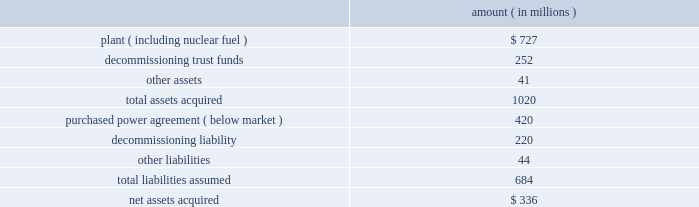Entergy corporation and subsidiaries notes to financial statements amount ( in millions ) .
Subsequent to the closing , entergy received approximately $ 6 million from consumers energy company as part of the post-closing adjustment defined in the asset sale agreement .
The post-closing adjustment amount resulted in an approximately $ 6 million reduction in plant and a corresponding reduction in other liabilities .
For the ppa , which was at below-market prices at the time of the acquisition , non-utility nuclear will amortize a liability to revenue over the life of the agreement .
The amount that will be amortized each period is based upon the difference between the present value calculated at the date of acquisition of each year's difference between revenue under the agreement and revenue based on estimated market prices .
Amounts amortized to revenue were $ 53 million in 2009 , $ 76 million in 2008 , and $ 50 million in 2007 .
The amounts to be amortized to revenue for the next five years will be $ 46 million for 2010 , $ 43 million for 2011 , $ 17 million in 2012 , $ 18 million for 2013 , and $ 16 million for 2014 .
Nypa value sharing agreements non-utility nuclear's purchase of the fitzpatrick and indian point 3 plants from nypa included value sharing agreements with nypa .
In october 2007 , non-utility nuclear and nypa amended and restated the value sharing agreements to clarify and amend certain provisions of the original terms .
Under the amended value sharing agreements , non-utility nuclear will make annual payments to nypa based on the generation output of the indian point 3 and fitzpatrick plants from january 2007 through december 2014 .
Non-utility nuclear will pay nypa $ 6.59 per mwh for power sold from indian point 3 , up to an annual cap of $ 48 million , and $ 3.91 per mwh for power sold from fitzpatrick , up to an annual cap of $ 24 million .
The annual payment for each year's output is due by january 15 of the following year .
Non-utility nuclear will record its liability for payments to nypa as power is generated and sold by indian point 3 and fitzpatrick .
An amount equal to the liability will be recorded to the plant asset account as contingent purchase price consideration for the plants .
In 2009 , 2008 , and 2007 , non-utility nuclear recorded $ 72 million as plant for generation during each of those years .
This amount will be depreciated over the expected remaining useful life of the plants .
In august 2008 , non-utility nuclear entered into a resolution of a dispute with nypa over the applicability of the value sharing agreements to its fitzpatrick and indian point 3 nuclear power plants after the planned spin-off of the non-utility nuclear business .
Under the resolution , non-utility nuclear agreed not to treat the separation as a "cessation event" that would terminate its obligation to make the payments under the value sharing agreements .
As a result , after the spin-off transaction , enexus will continue to be obligated to make payments to nypa under the amended and restated value sharing agreements. .
What is the total amount amortized to revenue in the last three years , ( in millions ) ? 
Computations: ((53 + 76) + 50)
Answer: 179.0. Entergy corporation and subsidiaries notes to financial statements amount ( in millions ) .
Subsequent to the closing , entergy received approximately $ 6 million from consumers energy company as part of the post-closing adjustment defined in the asset sale agreement .
The post-closing adjustment amount resulted in an approximately $ 6 million reduction in plant and a corresponding reduction in other liabilities .
For the ppa , which was at below-market prices at the time of the acquisition , non-utility nuclear will amortize a liability to revenue over the life of the agreement .
The amount that will be amortized each period is based upon the difference between the present value calculated at the date of acquisition of each year's difference between revenue under the agreement and revenue based on estimated market prices .
Amounts amortized to revenue were $ 53 million in 2009 , $ 76 million in 2008 , and $ 50 million in 2007 .
The amounts to be amortized to revenue for the next five years will be $ 46 million for 2010 , $ 43 million for 2011 , $ 17 million in 2012 , $ 18 million for 2013 , and $ 16 million for 2014 .
Nypa value sharing agreements non-utility nuclear's purchase of the fitzpatrick and indian point 3 plants from nypa included value sharing agreements with nypa .
In october 2007 , non-utility nuclear and nypa amended and restated the value sharing agreements to clarify and amend certain provisions of the original terms .
Under the amended value sharing agreements , non-utility nuclear will make annual payments to nypa based on the generation output of the indian point 3 and fitzpatrick plants from january 2007 through december 2014 .
Non-utility nuclear will pay nypa $ 6.59 per mwh for power sold from indian point 3 , up to an annual cap of $ 48 million , and $ 3.91 per mwh for power sold from fitzpatrick , up to an annual cap of $ 24 million .
The annual payment for each year's output is due by january 15 of the following year .
Non-utility nuclear will record its liability for payments to nypa as power is generated and sold by indian point 3 and fitzpatrick .
An amount equal to the liability will be recorded to the plant asset account as contingent purchase price consideration for the plants .
In 2009 , 2008 , and 2007 , non-utility nuclear recorded $ 72 million as plant for generation during each of those years .
This amount will be depreciated over the expected remaining useful life of the plants .
In august 2008 , non-utility nuclear entered into a resolution of a dispute with nypa over the applicability of the value sharing agreements to its fitzpatrick and indian point 3 nuclear power plants after the planned spin-off of the non-utility nuclear business .
Under the resolution , non-utility nuclear agreed not to treat the separation as a "cessation event" that would terminate its obligation to make the payments under the value sharing agreements .
As a result , after the spin-off transaction , enexus will continue to be obligated to make payments to nypa under the amended and restated value sharing agreements. .
What percentage of total acquired assets is related to plant acquisition? 
Computations: (727 / 1020)
Answer: 0.71275. Entergy corporation and subsidiaries notes to financial statements amount ( in millions ) .
Subsequent to the closing , entergy received approximately $ 6 million from consumers energy company as part of the post-closing adjustment defined in the asset sale agreement .
The post-closing adjustment amount resulted in an approximately $ 6 million reduction in plant and a corresponding reduction in other liabilities .
For the ppa , which was at below-market prices at the time of the acquisition , non-utility nuclear will amortize a liability to revenue over the life of the agreement .
The amount that will be amortized each period is based upon the difference between the present value calculated at the date of acquisition of each year's difference between revenue under the agreement and revenue based on estimated market prices .
Amounts amortized to revenue were $ 53 million in 2009 , $ 76 million in 2008 , and $ 50 million in 2007 .
The amounts to be amortized to revenue for the next five years will be $ 46 million for 2010 , $ 43 million for 2011 , $ 17 million in 2012 , $ 18 million for 2013 , and $ 16 million for 2014 .
Nypa value sharing agreements non-utility nuclear's purchase of the fitzpatrick and indian point 3 plants from nypa included value sharing agreements with nypa .
In october 2007 , non-utility nuclear and nypa amended and restated the value sharing agreements to clarify and amend certain provisions of the original terms .
Under the amended value sharing agreements , non-utility nuclear will make annual payments to nypa based on the generation output of the indian point 3 and fitzpatrick plants from january 2007 through december 2014 .
Non-utility nuclear will pay nypa $ 6.59 per mwh for power sold from indian point 3 , up to an annual cap of $ 48 million , and $ 3.91 per mwh for power sold from fitzpatrick , up to an annual cap of $ 24 million .
The annual payment for each year's output is due by january 15 of the following year .
Non-utility nuclear will record its liability for payments to nypa as power is generated and sold by indian point 3 and fitzpatrick .
An amount equal to the liability will be recorded to the plant asset account as contingent purchase price consideration for the plants .
In 2009 , 2008 , and 2007 , non-utility nuclear recorded $ 72 million as plant for generation during each of those years .
This amount will be depreciated over the expected remaining useful life of the plants .
In august 2008 , non-utility nuclear entered into a resolution of a dispute with nypa over the applicability of the value sharing agreements to its fitzpatrick and indian point 3 nuclear power plants after the planned spin-off of the non-utility nuclear business .
Under the resolution , non-utility nuclear agreed not to treat the separation as a "cessation event" that would terminate its obligation to make the payments under the value sharing agreements .
As a result , after the spin-off transaction , enexus will continue to be obligated to make payments to nypa under the amended and restated value sharing agreements. .
What was the total debt to the assets of the items acquired? 
Computations: (684 / 1020)
Answer: 0.67059. Entergy corporation and subsidiaries notes to financial statements ouachita in september 2008 , entergy arkansas purchased the ouachita plant , a 789 mw three-train gas-fired combined cycle generating turbine ( ccgt ) electric power plant located 20 miles south of the arkansas state line near sterlington , louisiana , for approximately $ 210 million from a subsidiary of cogentrix energy , inc .
Entergy arkansas received the plant , materials and supplies , and related real estate in the transaction .
The ferc and the apsc approved the acquisition .
The apsc also approved the recovery of the acquisition and ownership costs through a rate rider and the planned sale of one-third of the capacity and energy to entergy gulf states louisiana .
The lpsc also approved the purchase of one-third of the capacity and energy by entergy gulf states louisiana , subject to certain conditions , including a study to determine the costs and benefits of entergy gulf states louisiana exercising an option to purchase one-third of the plant ( unit 3 ) from entergy arkansas .
Entergy gulf states louisiana is scheduled to report the results of that study by march 30 , 2009 .
Palisades in april 2007 , entergy's non-utility nuclear business purchased the 798 mw palisades nuclear energy plant located near south haven , michigan from consumers energy company for a net cash payment of $ 336 million .
Entergy received the plant , nuclear fuel , inventories , and other assets .
The liability to decommission the plant , as well as related decommissioning trust funds , was also transferred to entergy's non-utility nuclear business .
Entergy's non-utility nuclear business executed a unit-contingent , 15-year purchased power agreement ( ppa ) with consumers energy for 100% ( 100 % ) of the plant's output , excluding any future uprates .
Prices under the ppa range from $ 43.50/mwh in 2007 to $ 61.50/mwh in 2022 , and the average price under the ppa is $ 51/mwh .
In the first quarter 2007 , the nrc renewed palisades' operating license until 2031 .
As part of the transaction , entergy's non- utility nuclear business assumed responsibility for spent fuel at the decommissioned big rock point nuclear plant , which is located near charlevoix , michigan .
Palisades' financial results since april 2007 are included in entergy's non-utility nuclear business segment .
The table summarizes the assets acquired and liabilities assumed at the date of acquisition .
Amount ( in millions ) .
Subsequent to the closing , entergy received approximately $ 6 million from consumers energy company as part of the post-closing adjustment defined in the asset sale agreement .
The post-closing adjustment amount resulted in an approximately $ 6 million reduction in plant and a corresponding reduction in other liabilities .
For the ppa , which was at below-market prices at the time of the acquisition , non-utility nuclear will amortize a liability to revenue over the life of the agreement .
The amount that will be amortized each period is based upon the difference between the present value calculated at the date of acquisition of each year's difference between revenue under the agreement and revenue based on estimated market prices .
Amounts amortized to revenue were $ 76 .
What is the assumed debt to acquired asset ratio? 
Computations: (684 / 1020)
Answer: 0.67059. 